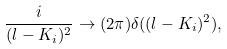Convert formula to latex. <formula><loc_0><loc_0><loc_500><loc_500>\frac { i } { ( l - K _ { i } ) ^ { 2 } } \rightarrow ( 2 \pi ) \delta ( ( l - K _ { i } ) ^ { 2 } ) ,</formula> 